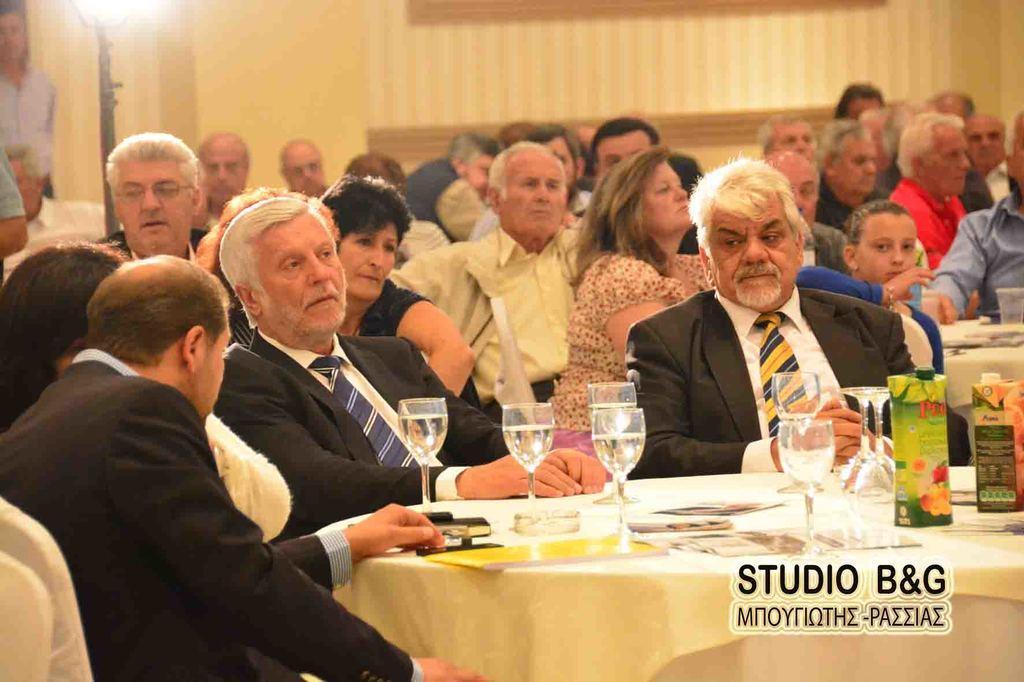Could you give a brief overview of what you see in this image? In this image we can see persons sitting on the chairs and tables are placed in front of them. On the tables there are wine glasses, printed cards and juice cartons. 